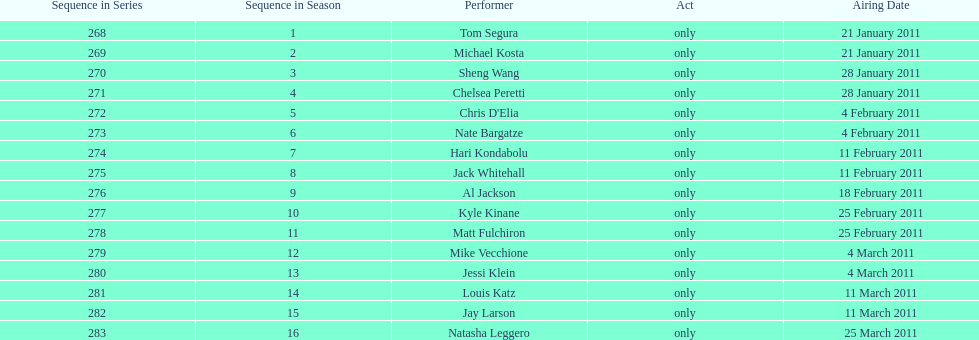What were the total number of air dates in february? 7. 